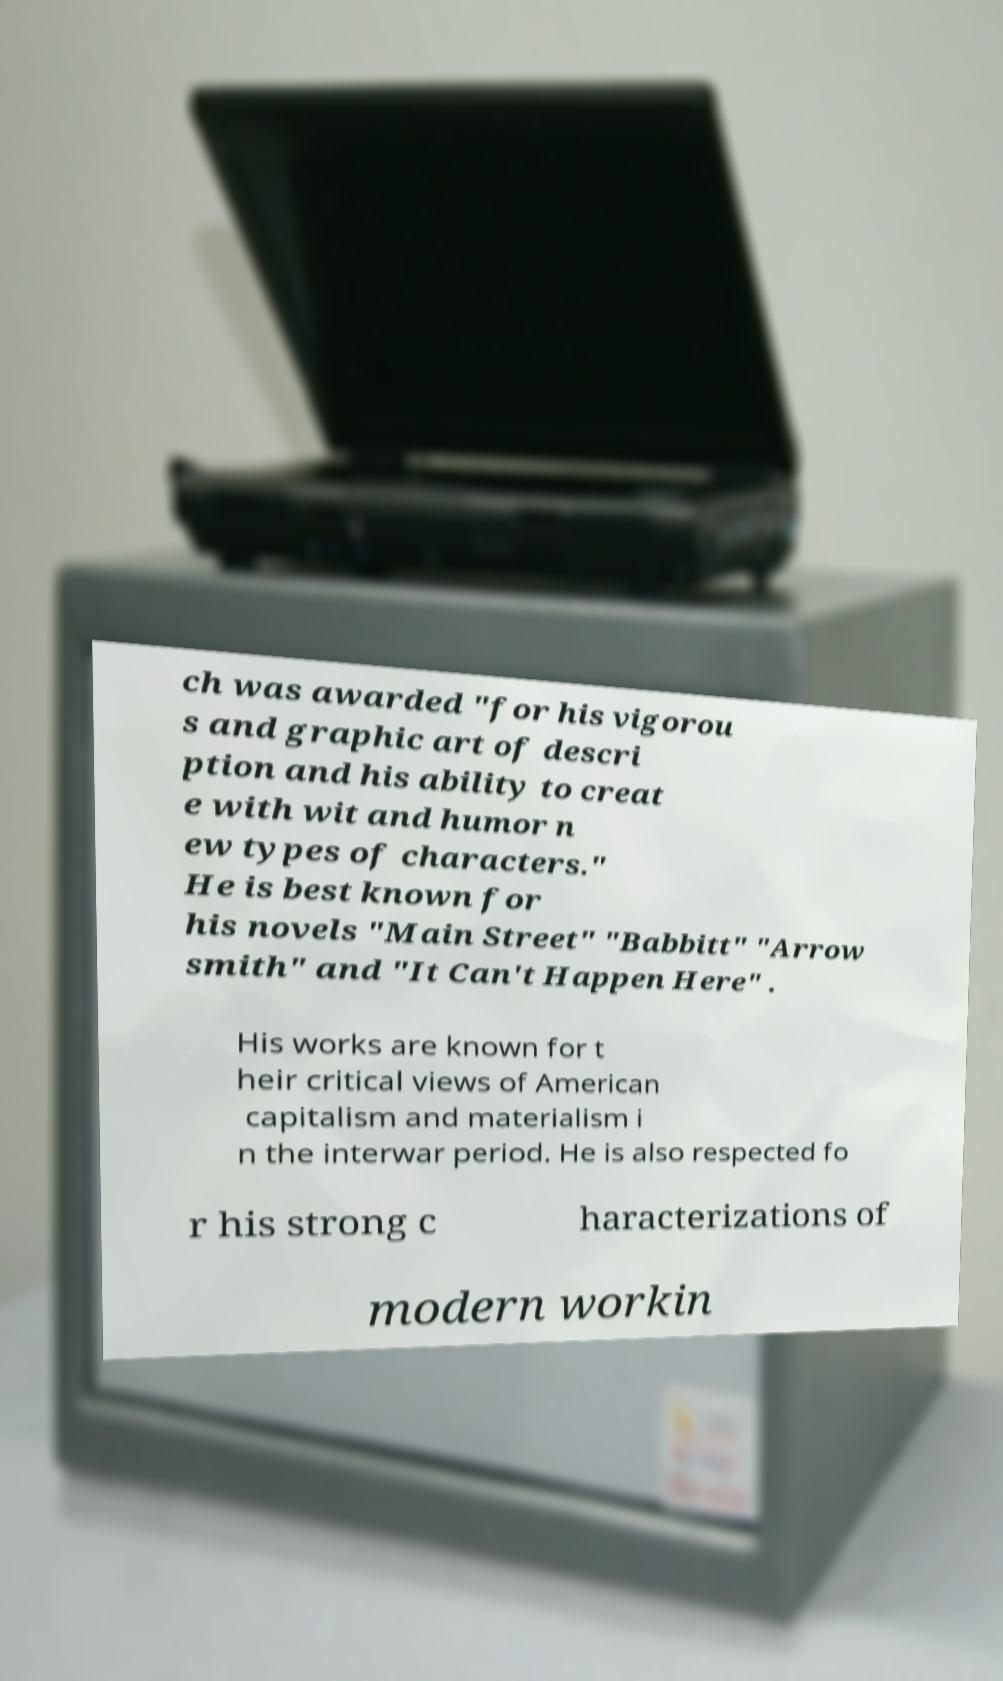Please identify and transcribe the text found in this image. ch was awarded "for his vigorou s and graphic art of descri ption and his ability to creat e with wit and humor n ew types of characters." He is best known for his novels "Main Street" "Babbitt" "Arrow smith" and "It Can't Happen Here" . His works are known for t heir critical views of American capitalism and materialism i n the interwar period. He is also respected fo r his strong c haracterizations of modern workin 